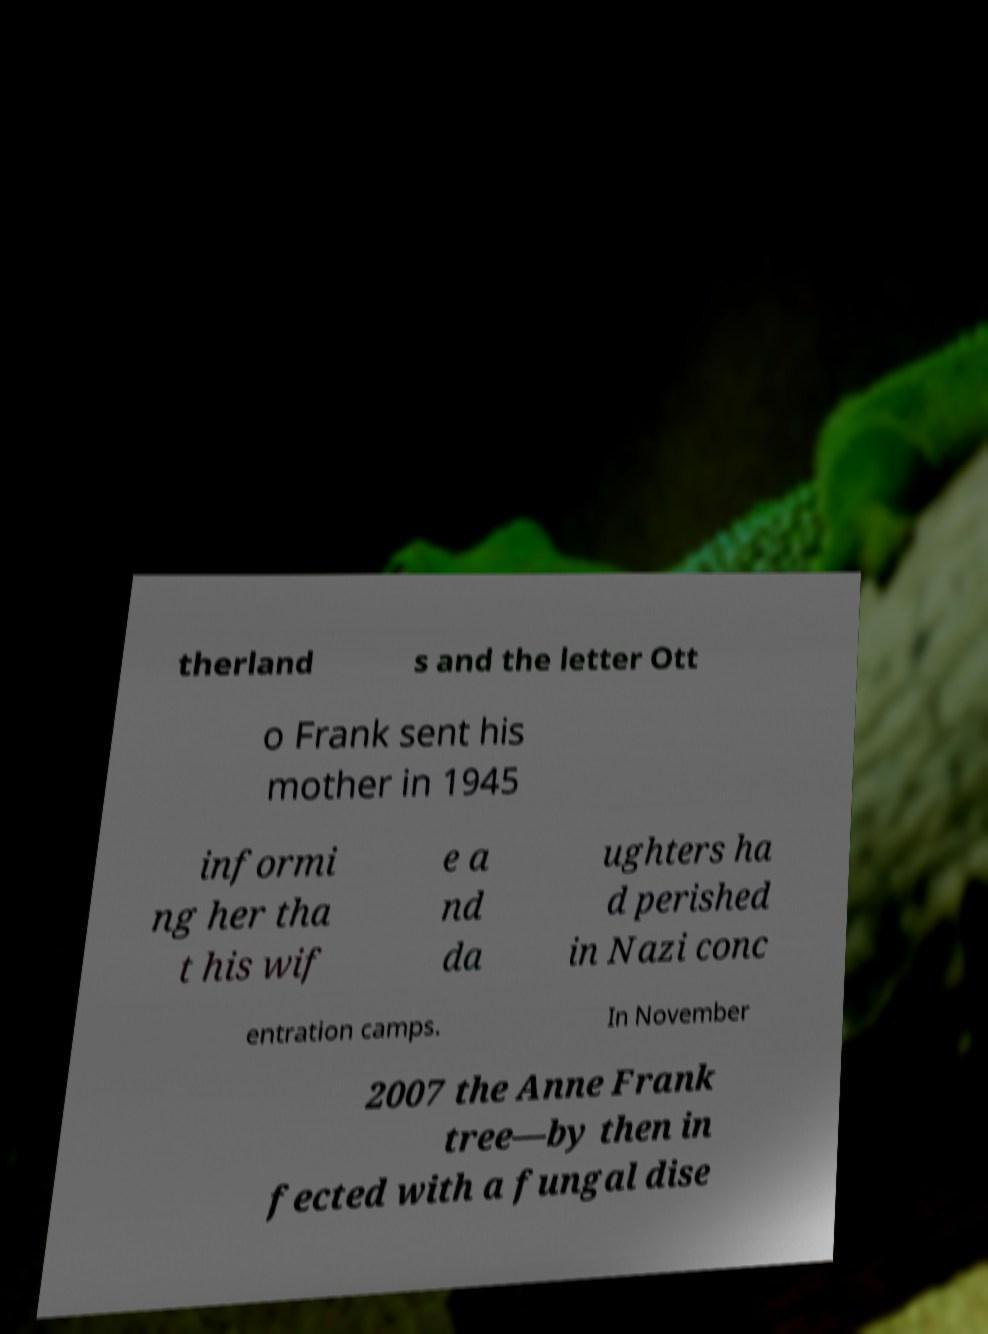Please read and relay the text visible in this image. What does it say? therland s and the letter Ott o Frank sent his mother in 1945 informi ng her tha t his wif e a nd da ughters ha d perished in Nazi conc entration camps. In November 2007 the Anne Frank tree—by then in fected with a fungal dise 